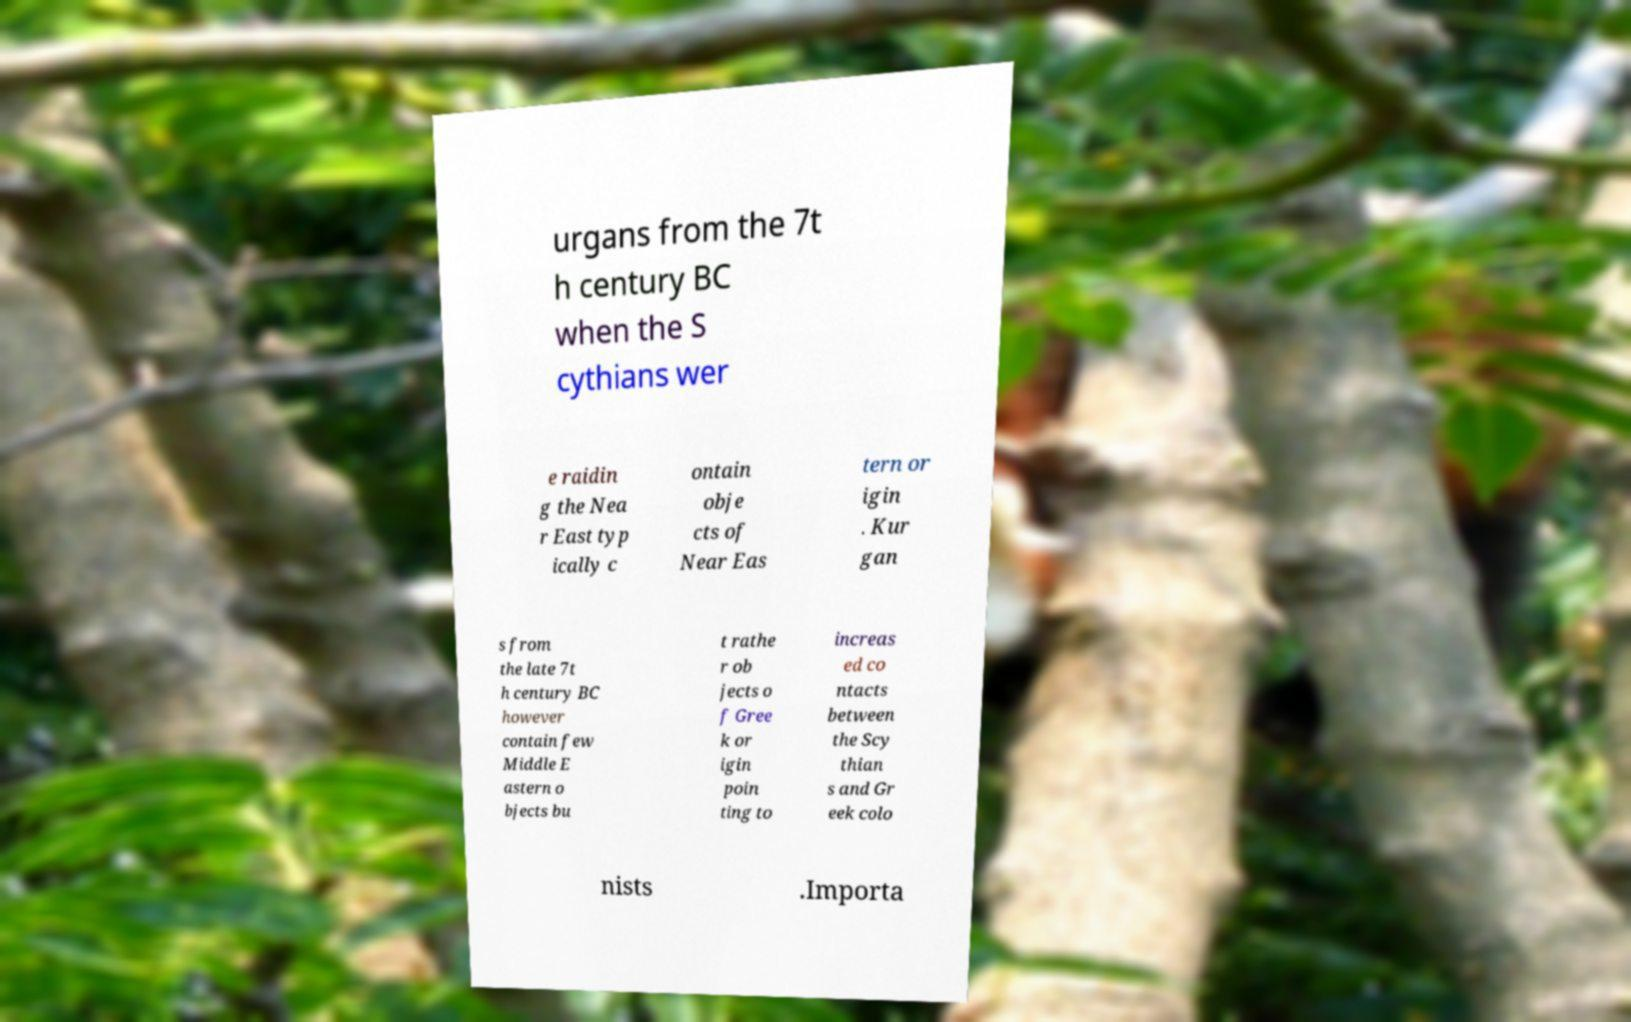Can you read and provide the text displayed in the image?This photo seems to have some interesting text. Can you extract and type it out for me? urgans from the 7t h century BC when the S cythians wer e raidin g the Nea r East typ ically c ontain obje cts of Near Eas tern or igin . Kur gan s from the late 7t h century BC however contain few Middle E astern o bjects bu t rathe r ob jects o f Gree k or igin poin ting to increas ed co ntacts between the Scy thian s and Gr eek colo nists .Importa 